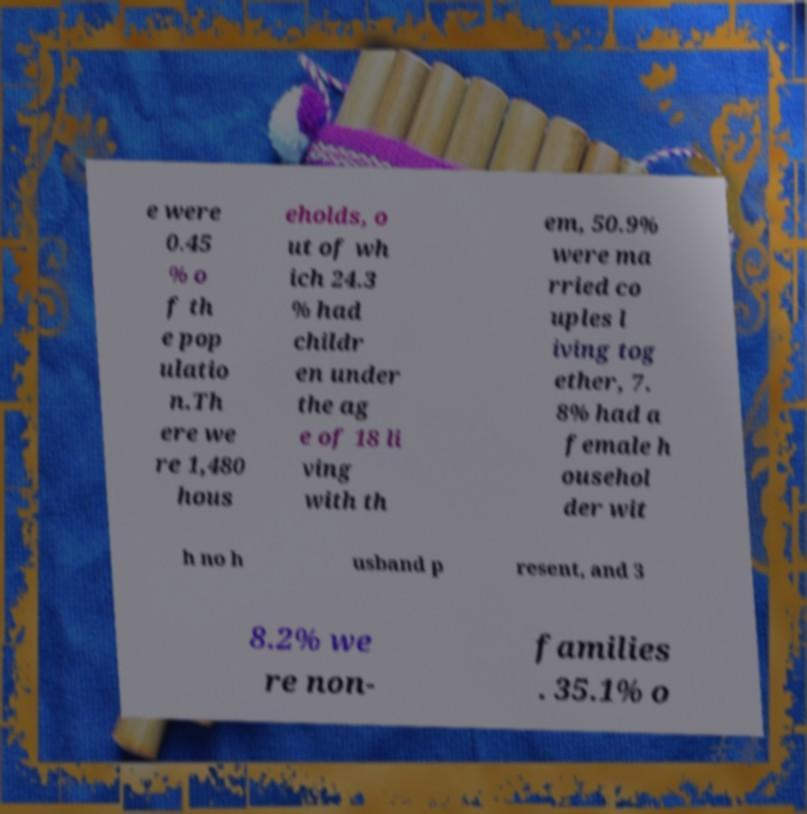I need the written content from this picture converted into text. Can you do that? e were 0.45 % o f th e pop ulatio n.Th ere we re 1,480 hous eholds, o ut of wh ich 24.3 % had childr en under the ag e of 18 li ving with th em, 50.9% were ma rried co uples l iving tog ether, 7. 8% had a female h ousehol der wit h no h usband p resent, and 3 8.2% we re non- families . 35.1% o 